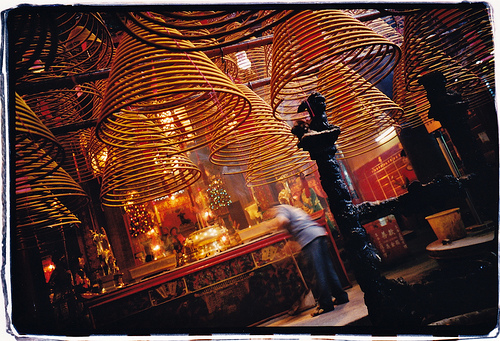<image>
Is the lamp in front of the man? Yes. The lamp is positioned in front of the man, appearing closer to the camera viewpoint. 